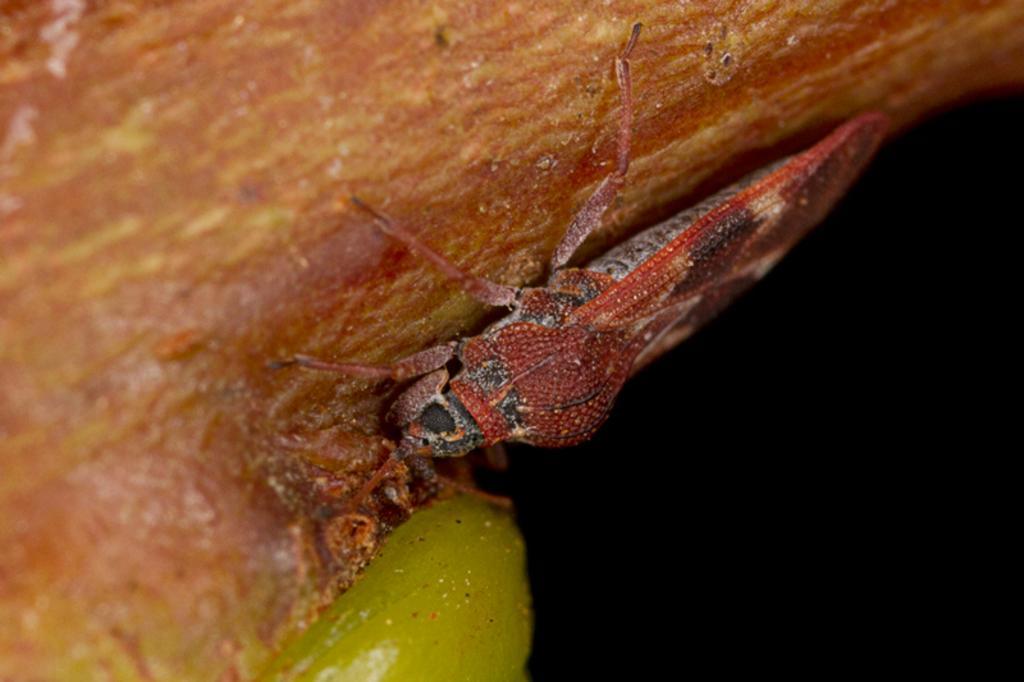Describe this image in one or two sentences. In this image there is a insect on brown color food. 